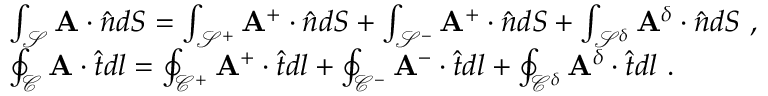Convert formula to latex. <formula><loc_0><loc_0><loc_500><loc_500>\begin{array} { r l } & { \int _ { \mathcal { S } } A \cdot \hat { n } d S = \int _ { \mathcal { S } ^ { + } } A ^ { + } \cdot \hat { n } d S + \int _ { \mathcal { S } ^ { - } } A ^ { + } \cdot \hat { n } d S + \int _ { \mathcal { S } ^ { \delta } } A ^ { \delta } \cdot \hat { n } d S , } \\ & { \oint _ { \mathcal { C } } A \cdot \hat { t } d l = \oint _ { \mathcal { C } ^ { + } } A ^ { + } \cdot \hat { t } d l + \oint _ { \mathcal { C } ^ { - } } A ^ { - } \cdot \hat { t } d l + \oint _ { \mathcal { C } ^ { \delta } } A ^ { \delta } \cdot \hat { t } d l . } \end{array}</formula> 